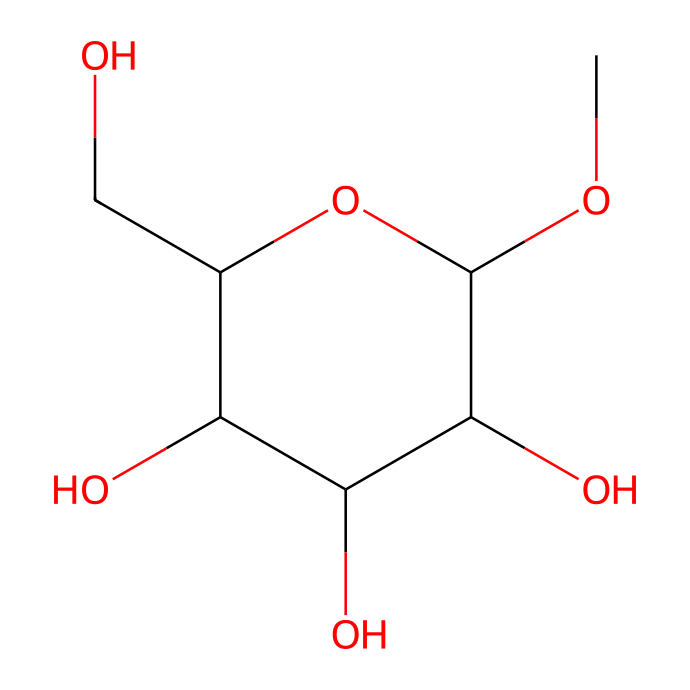How many hydroxyl groups are present in this chemical? By examining the SMILES representation, we can identify the hydroxyl groups. Each '[H]O' represents a hydroxyl (-OH) group. In the structural representation, there are multiple '[H]OC' segments indicating the presence of four -OH groups attached to the carbon backbone.
Answer: four What is the molecular formula of this compound? The molecular formula can be derived from the SMILES notation by counting the number of each type of atom present. The chemical indicates there are 10 carbons (C), 12 hydrogens (H), and 6 oxygens (O), giving the formula C10H12O6.
Answer: C10H12O6 Is this compound a polymer? The structure contains repeating units and displays characteristics typical of polysaccharides, which are polymers made of sugar molecules. Therefore, it can be classified as a polymer due to its long chain structure of interlinked sugar units.
Answer: yes What is the role of methylcellulose in food products? Methylcellulose functions primarily as a thickener and emulsifier in food products, crucial for retaining moisture and providing texture. Its physicochemical properties allow it to create a gel-like consistency when hydrated, optimizing the structure of meat substitutes.
Answer: thickener How does methylcellulose behave when heated? Methylcellulose demonstrates unique behavior as it is thermoreversible; it gels upon heating and liquefies when cooled. This phenomenon occurs because the polymer chains rearrange as temperature changes, differentiating it from typical Newtonian fluids.
Answer: thermoreversible What type of fluid is methylcellulose classified as? Methylcellulose is classified as a non-Newtonian fluid since its viscosity changes with the shear rate or stress applied to it, unlike Newtonian fluids which have constant viscosity. This behavior is characteristic of many polymers in solution.
Answer: non-Newtonian 